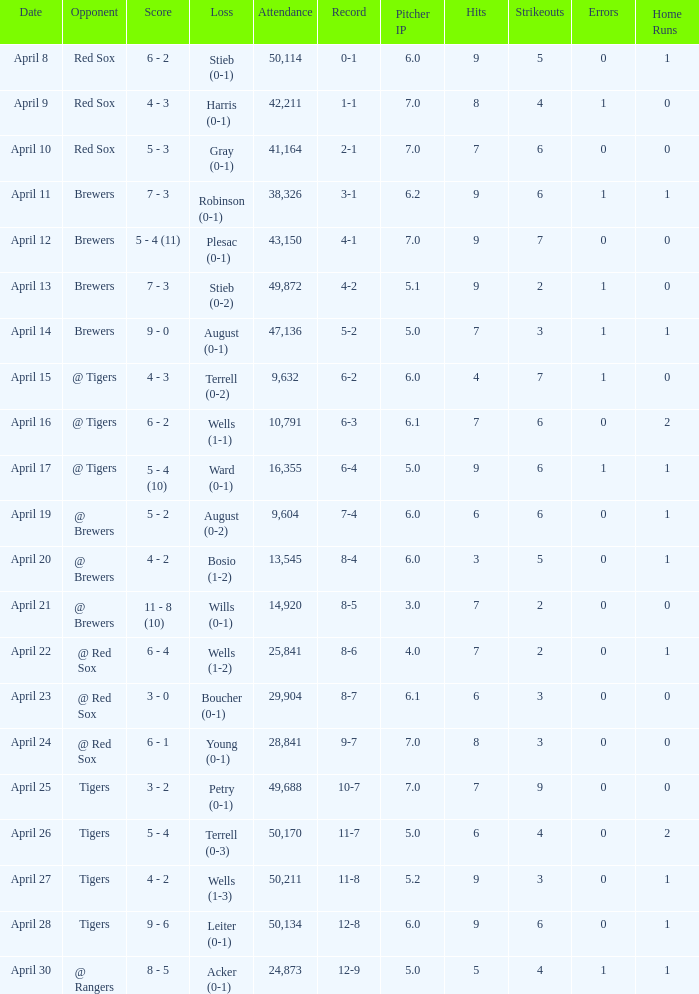Which opponent has a loss of wells (1-3)? Tigers. 